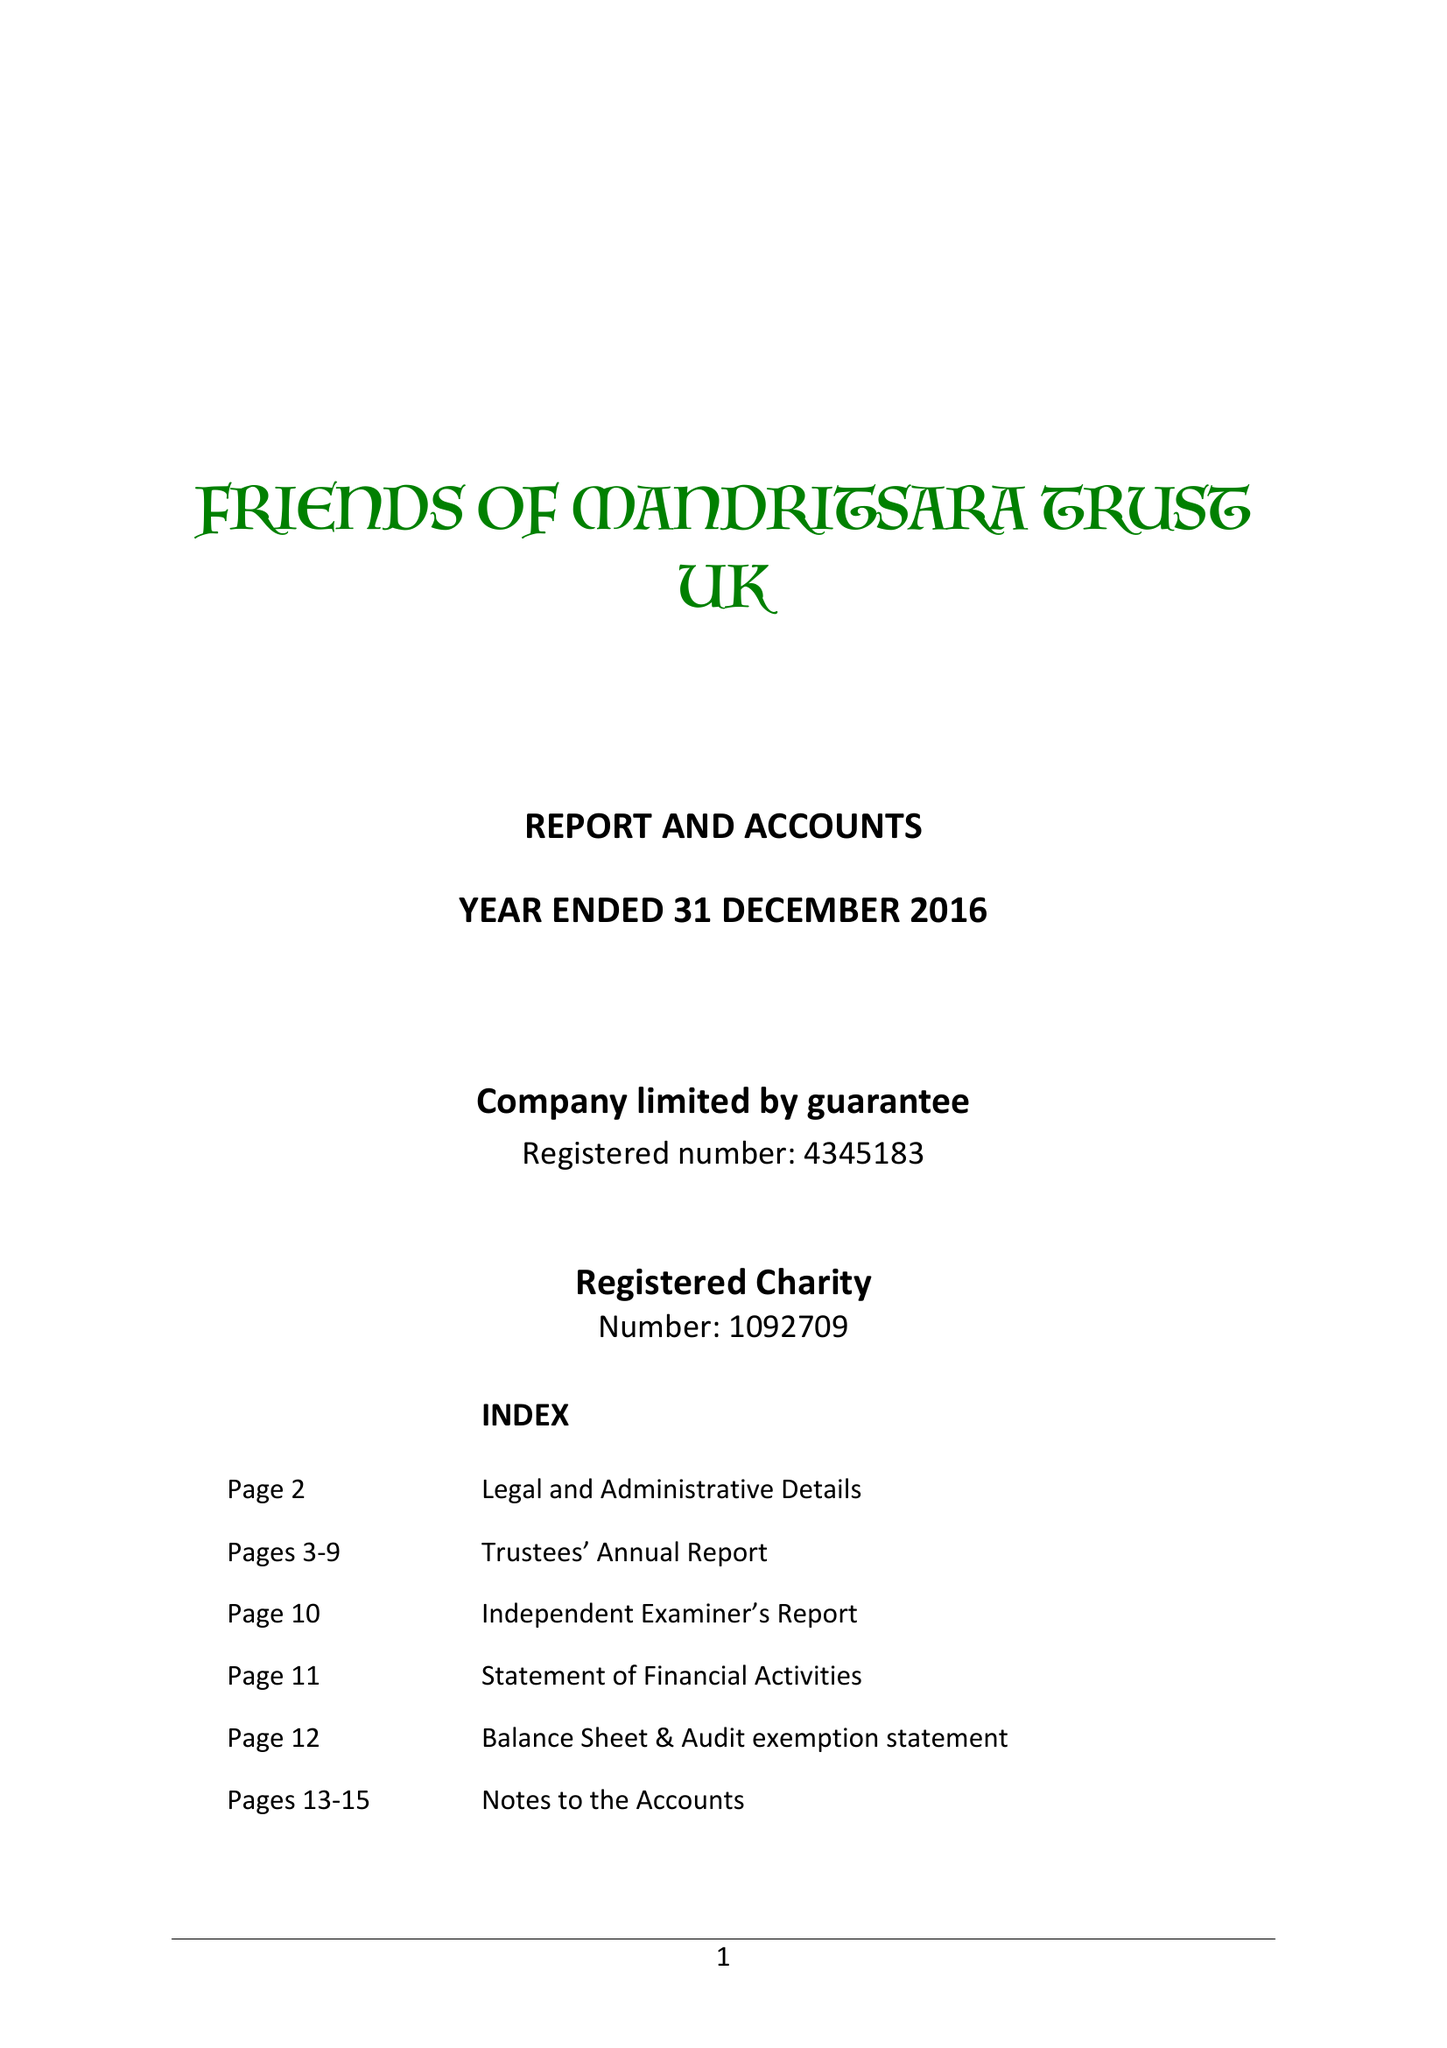What is the value for the report_date?
Answer the question using a single word or phrase. 2016-12-31 